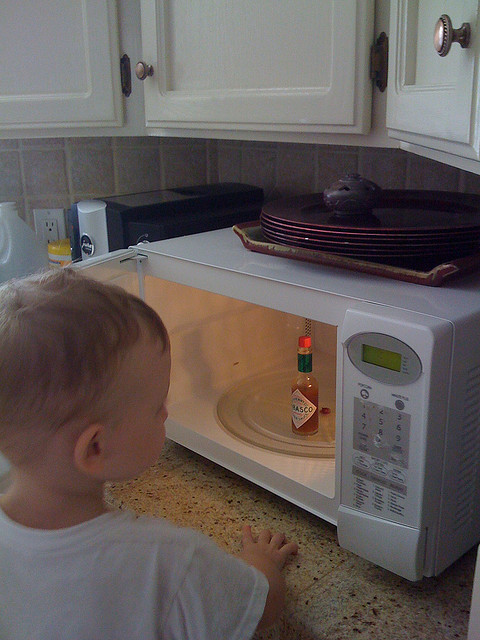Identify the text displayed in this image. MASCO 